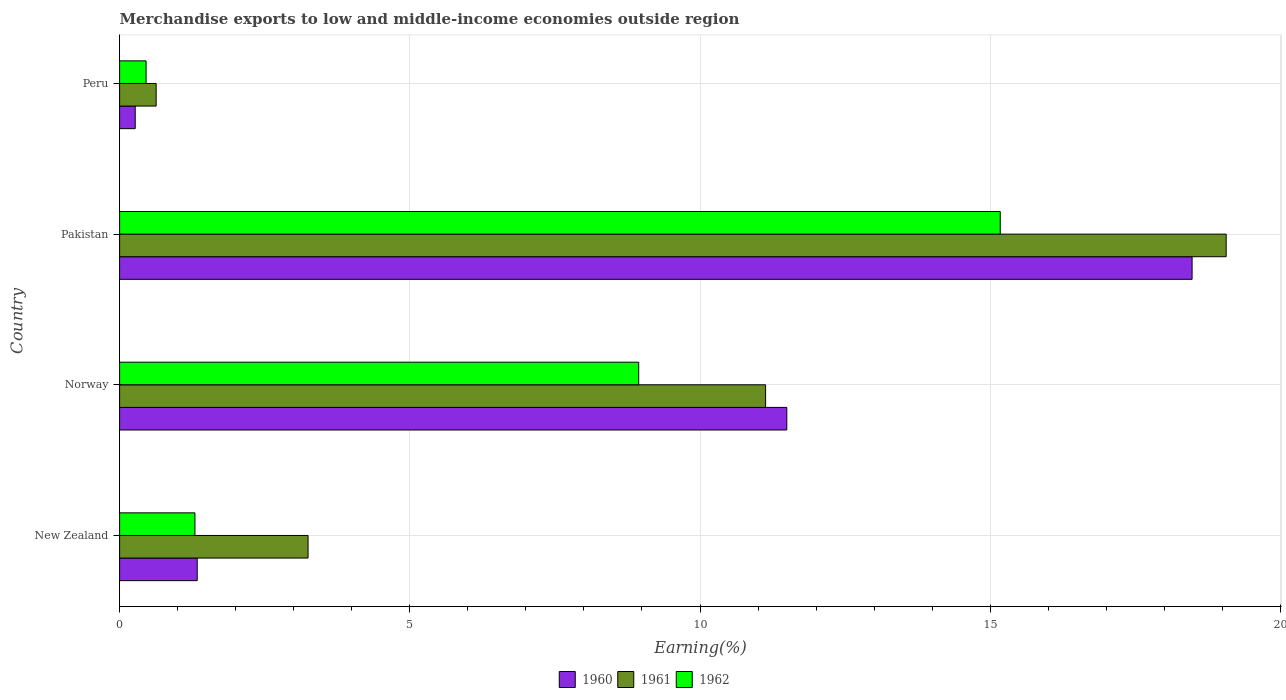How many different coloured bars are there?
Give a very brief answer. 3. How many groups of bars are there?
Provide a succinct answer. 4. How many bars are there on the 1st tick from the top?
Keep it short and to the point. 3. What is the label of the 4th group of bars from the top?
Offer a terse response. New Zealand. What is the percentage of amount earned from merchandise exports in 1961 in Norway?
Your answer should be very brief. 11.13. Across all countries, what is the maximum percentage of amount earned from merchandise exports in 1960?
Give a very brief answer. 18.48. Across all countries, what is the minimum percentage of amount earned from merchandise exports in 1961?
Keep it short and to the point. 0.63. What is the total percentage of amount earned from merchandise exports in 1960 in the graph?
Offer a very short reply. 31.58. What is the difference between the percentage of amount earned from merchandise exports in 1962 in New Zealand and that in Pakistan?
Ensure brevity in your answer.  -13.88. What is the difference between the percentage of amount earned from merchandise exports in 1962 in New Zealand and the percentage of amount earned from merchandise exports in 1960 in Norway?
Offer a terse response. -10.2. What is the average percentage of amount earned from merchandise exports in 1962 per country?
Provide a succinct answer. 6.47. What is the difference between the percentage of amount earned from merchandise exports in 1961 and percentage of amount earned from merchandise exports in 1962 in Norway?
Your response must be concise. 2.19. In how many countries, is the percentage of amount earned from merchandise exports in 1960 greater than 11 %?
Provide a short and direct response. 2. What is the ratio of the percentage of amount earned from merchandise exports in 1961 in New Zealand to that in Pakistan?
Offer a very short reply. 0.17. Is the percentage of amount earned from merchandise exports in 1960 in New Zealand less than that in Pakistan?
Your answer should be very brief. Yes. Is the difference between the percentage of amount earned from merchandise exports in 1961 in Pakistan and Peru greater than the difference between the percentage of amount earned from merchandise exports in 1962 in Pakistan and Peru?
Provide a short and direct response. Yes. What is the difference between the highest and the second highest percentage of amount earned from merchandise exports in 1960?
Your response must be concise. 6.98. What is the difference between the highest and the lowest percentage of amount earned from merchandise exports in 1960?
Offer a terse response. 18.21. What does the 1st bar from the top in New Zealand represents?
Offer a very short reply. 1962. Are all the bars in the graph horizontal?
Your answer should be very brief. Yes. How many countries are there in the graph?
Offer a very short reply. 4. Are the values on the major ticks of X-axis written in scientific E-notation?
Your answer should be very brief. No. Does the graph contain grids?
Your answer should be compact. Yes. What is the title of the graph?
Keep it short and to the point. Merchandise exports to low and middle-income economies outside region. Does "1993" appear as one of the legend labels in the graph?
Provide a succinct answer. No. What is the label or title of the X-axis?
Make the answer very short. Earning(%). What is the label or title of the Y-axis?
Ensure brevity in your answer.  Country. What is the Earning(%) of 1960 in New Zealand?
Your answer should be compact. 1.34. What is the Earning(%) in 1961 in New Zealand?
Ensure brevity in your answer.  3.25. What is the Earning(%) in 1962 in New Zealand?
Offer a terse response. 1.3. What is the Earning(%) of 1960 in Norway?
Ensure brevity in your answer.  11.5. What is the Earning(%) of 1961 in Norway?
Provide a short and direct response. 11.13. What is the Earning(%) in 1962 in Norway?
Give a very brief answer. 8.94. What is the Earning(%) of 1960 in Pakistan?
Provide a short and direct response. 18.48. What is the Earning(%) of 1961 in Pakistan?
Offer a terse response. 19.07. What is the Earning(%) of 1962 in Pakistan?
Give a very brief answer. 15.17. What is the Earning(%) in 1960 in Peru?
Keep it short and to the point. 0.27. What is the Earning(%) in 1961 in Peru?
Provide a short and direct response. 0.63. What is the Earning(%) of 1962 in Peru?
Ensure brevity in your answer.  0.46. Across all countries, what is the maximum Earning(%) of 1960?
Make the answer very short. 18.48. Across all countries, what is the maximum Earning(%) of 1961?
Make the answer very short. 19.07. Across all countries, what is the maximum Earning(%) in 1962?
Offer a terse response. 15.17. Across all countries, what is the minimum Earning(%) in 1960?
Provide a succinct answer. 0.27. Across all countries, what is the minimum Earning(%) of 1961?
Ensure brevity in your answer.  0.63. Across all countries, what is the minimum Earning(%) in 1962?
Keep it short and to the point. 0.46. What is the total Earning(%) in 1960 in the graph?
Give a very brief answer. 31.58. What is the total Earning(%) of 1961 in the graph?
Your answer should be very brief. 34.07. What is the total Earning(%) of 1962 in the graph?
Give a very brief answer. 25.87. What is the difference between the Earning(%) of 1960 in New Zealand and that in Norway?
Ensure brevity in your answer.  -10.16. What is the difference between the Earning(%) of 1961 in New Zealand and that in Norway?
Provide a succinct answer. -7.88. What is the difference between the Earning(%) in 1962 in New Zealand and that in Norway?
Make the answer very short. -7.65. What is the difference between the Earning(%) of 1960 in New Zealand and that in Pakistan?
Give a very brief answer. -17.14. What is the difference between the Earning(%) in 1961 in New Zealand and that in Pakistan?
Your response must be concise. -15.82. What is the difference between the Earning(%) of 1962 in New Zealand and that in Pakistan?
Provide a succinct answer. -13.88. What is the difference between the Earning(%) of 1960 in New Zealand and that in Peru?
Provide a short and direct response. 1.07. What is the difference between the Earning(%) in 1961 in New Zealand and that in Peru?
Provide a short and direct response. 2.62. What is the difference between the Earning(%) in 1962 in New Zealand and that in Peru?
Your answer should be very brief. 0.84. What is the difference between the Earning(%) in 1960 in Norway and that in Pakistan?
Make the answer very short. -6.98. What is the difference between the Earning(%) of 1961 in Norway and that in Pakistan?
Ensure brevity in your answer.  -7.94. What is the difference between the Earning(%) of 1962 in Norway and that in Pakistan?
Provide a short and direct response. -6.23. What is the difference between the Earning(%) of 1960 in Norway and that in Peru?
Give a very brief answer. 11.23. What is the difference between the Earning(%) of 1961 in Norway and that in Peru?
Provide a short and direct response. 10.5. What is the difference between the Earning(%) in 1962 in Norway and that in Peru?
Provide a succinct answer. 8.49. What is the difference between the Earning(%) in 1960 in Pakistan and that in Peru?
Keep it short and to the point. 18.21. What is the difference between the Earning(%) in 1961 in Pakistan and that in Peru?
Provide a short and direct response. 18.44. What is the difference between the Earning(%) in 1962 in Pakistan and that in Peru?
Your answer should be compact. 14.72. What is the difference between the Earning(%) in 1960 in New Zealand and the Earning(%) in 1961 in Norway?
Provide a short and direct response. -9.79. What is the difference between the Earning(%) in 1960 in New Zealand and the Earning(%) in 1962 in Norway?
Offer a very short reply. -7.61. What is the difference between the Earning(%) of 1961 in New Zealand and the Earning(%) of 1962 in Norway?
Offer a very short reply. -5.7. What is the difference between the Earning(%) of 1960 in New Zealand and the Earning(%) of 1961 in Pakistan?
Offer a very short reply. -17.73. What is the difference between the Earning(%) in 1960 in New Zealand and the Earning(%) in 1962 in Pakistan?
Offer a terse response. -13.84. What is the difference between the Earning(%) of 1961 in New Zealand and the Earning(%) of 1962 in Pakistan?
Keep it short and to the point. -11.93. What is the difference between the Earning(%) of 1960 in New Zealand and the Earning(%) of 1961 in Peru?
Your answer should be compact. 0.71. What is the difference between the Earning(%) in 1960 in New Zealand and the Earning(%) in 1962 in Peru?
Keep it short and to the point. 0.88. What is the difference between the Earning(%) of 1961 in New Zealand and the Earning(%) of 1962 in Peru?
Your answer should be compact. 2.79. What is the difference between the Earning(%) of 1960 in Norway and the Earning(%) of 1961 in Pakistan?
Your answer should be very brief. -7.57. What is the difference between the Earning(%) of 1960 in Norway and the Earning(%) of 1962 in Pakistan?
Ensure brevity in your answer.  -3.68. What is the difference between the Earning(%) in 1961 in Norway and the Earning(%) in 1962 in Pakistan?
Your answer should be compact. -4.04. What is the difference between the Earning(%) in 1960 in Norway and the Earning(%) in 1961 in Peru?
Keep it short and to the point. 10.87. What is the difference between the Earning(%) in 1960 in Norway and the Earning(%) in 1962 in Peru?
Your answer should be compact. 11.04. What is the difference between the Earning(%) in 1961 in Norway and the Earning(%) in 1962 in Peru?
Your answer should be very brief. 10.67. What is the difference between the Earning(%) of 1960 in Pakistan and the Earning(%) of 1961 in Peru?
Offer a very short reply. 17.85. What is the difference between the Earning(%) of 1960 in Pakistan and the Earning(%) of 1962 in Peru?
Keep it short and to the point. 18.02. What is the difference between the Earning(%) in 1961 in Pakistan and the Earning(%) in 1962 in Peru?
Your answer should be very brief. 18.61. What is the average Earning(%) in 1960 per country?
Provide a succinct answer. 7.9. What is the average Earning(%) of 1961 per country?
Give a very brief answer. 8.52. What is the average Earning(%) of 1962 per country?
Your answer should be very brief. 6.47. What is the difference between the Earning(%) of 1960 and Earning(%) of 1961 in New Zealand?
Your response must be concise. -1.91. What is the difference between the Earning(%) in 1960 and Earning(%) in 1962 in New Zealand?
Your answer should be compact. 0.04. What is the difference between the Earning(%) of 1961 and Earning(%) of 1962 in New Zealand?
Your answer should be very brief. 1.95. What is the difference between the Earning(%) in 1960 and Earning(%) in 1961 in Norway?
Your answer should be very brief. 0.37. What is the difference between the Earning(%) in 1960 and Earning(%) in 1962 in Norway?
Offer a terse response. 2.55. What is the difference between the Earning(%) of 1961 and Earning(%) of 1962 in Norway?
Ensure brevity in your answer.  2.19. What is the difference between the Earning(%) of 1960 and Earning(%) of 1961 in Pakistan?
Make the answer very short. -0.59. What is the difference between the Earning(%) in 1960 and Earning(%) in 1962 in Pakistan?
Ensure brevity in your answer.  3.31. What is the difference between the Earning(%) in 1961 and Earning(%) in 1962 in Pakistan?
Provide a succinct answer. 3.89. What is the difference between the Earning(%) of 1960 and Earning(%) of 1961 in Peru?
Keep it short and to the point. -0.36. What is the difference between the Earning(%) of 1960 and Earning(%) of 1962 in Peru?
Offer a very short reply. -0.19. What is the difference between the Earning(%) of 1961 and Earning(%) of 1962 in Peru?
Your answer should be compact. 0.17. What is the ratio of the Earning(%) in 1960 in New Zealand to that in Norway?
Give a very brief answer. 0.12. What is the ratio of the Earning(%) in 1961 in New Zealand to that in Norway?
Your response must be concise. 0.29. What is the ratio of the Earning(%) of 1962 in New Zealand to that in Norway?
Offer a terse response. 0.15. What is the ratio of the Earning(%) in 1960 in New Zealand to that in Pakistan?
Provide a short and direct response. 0.07. What is the ratio of the Earning(%) in 1961 in New Zealand to that in Pakistan?
Make the answer very short. 0.17. What is the ratio of the Earning(%) in 1962 in New Zealand to that in Pakistan?
Offer a very short reply. 0.09. What is the ratio of the Earning(%) of 1960 in New Zealand to that in Peru?
Offer a very short reply. 4.97. What is the ratio of the Earning(%) in 1961 in New Zealand to that in Peru?
Your answer should be very brief. 5.16. What is the ratio of the Earning(%) in 1962 in New Zealand to that in Peru?
Give a very brief answer. 2.84. What is the ratio of the Earning(%) in 1960 in Norway to that in Pakistan?
Your answer should be compact. 0.62. What is the ratio of the Earning(%) in 1961 in Norway to that in Pakistan?
Provide a succinct answer. 0.58. What is the ratio of the Earning(%) in 1962 in Norway to that in Pakistan?
Provide a succinct answer. 0.59. What is the ratio of the Earning(%) of 1960 in Norway to that in Peru?
Offer a terse response. 42.72. What is the ratio of the Earning(%) of 1961 in Norway to that in Peru?
Your response must be concise. 17.67. What is the ratio of the Earning(%) in 1962 in Norway to that in Peru?
Provide a short and direct response. 19.59. What is the ratio of the Earning(%) of 1960 in Pakistan to that in Peru?
Provide a succinct answer. 68.67. What is the ratio of the Earning(%) of 1961 in Pakistan to that in Peru?
Give a very brief answer. 30.27. What is the ratio of the Earning(%) of 1962 in Pakistan to that in Peru?
Provide a short and direct response. 33.24. What is the difference between the highest and the second highest Earning(%) in 1960?
Make the answer very short. 6.98. What is the difference between the highest and the second highest Earning(%) of 1961?
Keep it short and to the point. 7.94. What is the difference between the highest and the second highest Earning(%) in 1962?
Keep it short and to the point. 6.23. What is the difference between the highest and the lowest Earning(%) in 1960?
Offer a terse response. 18.21. What is the difference between the highest and the lowest Earning(%) of 1961?
Offer a very short reply. 18.44. What is the difference between the highest and the lowest Earning(%) of 1962?
Offer a terse response. 14.72. 